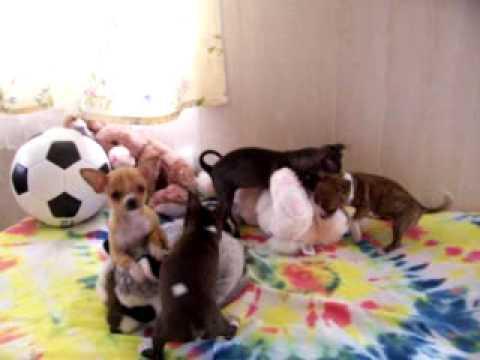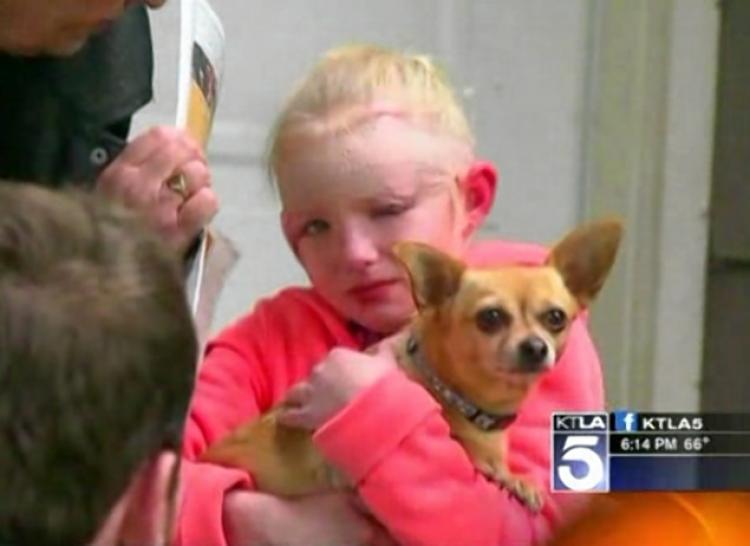The first image is the image on the left, the second image is the image on the right. Given the left and right images, does the statement "The left image has a carrot." hold true? Answer yes or no. No. The first image is the image on the left, the second image is the image on the right. Given the left and right images, does the statement "A dog has an orange carrot in an image that includes bunny ears." hold true? Answer yes or no. No. 